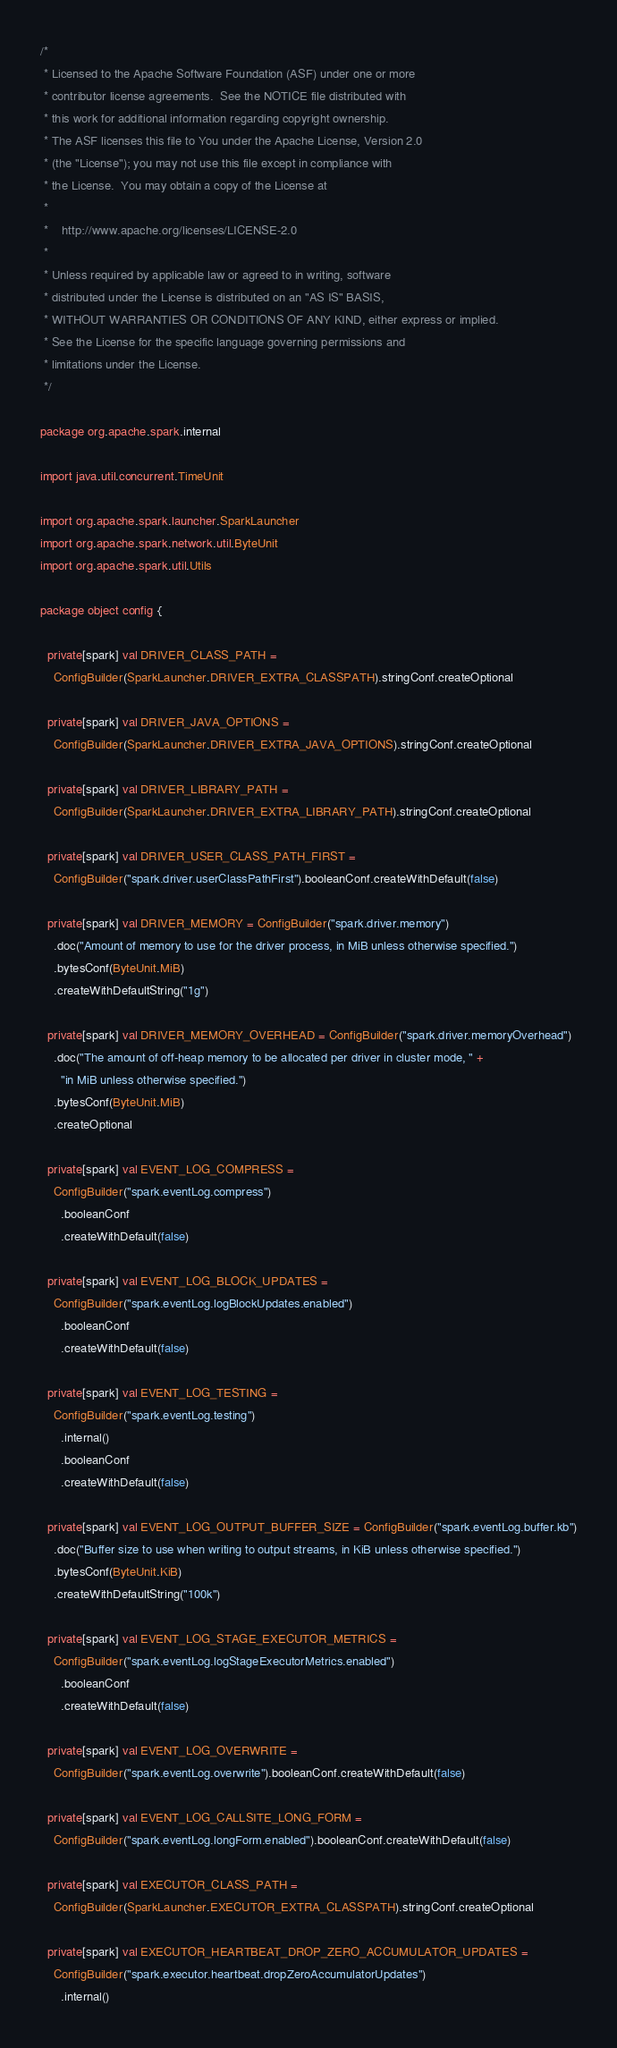<code> <loc_0><loc_0><loc_500><loc_500><_Scala_>/*
 * Licensed to the Apache Software Foundation (ASF) under one or more
 * contributor license agreements.  See the NOTICE file distributed with
 * this work for additional information regarding copyright ownership.
 * The ASF licenses this file to You under the Apache License, Version 2.0
 * (the "License"); you may not use this file except in compliance with
 * the License.  You may obtain a copy of the License at
 *
 *    http://www.apache.org/licenses/LICENSE-2.0
 *
 * Unless required by applicable law or agreed to in writing, software
 * distributed under the License is distributed on an "AS IS" BASIS,
 * WITHOUT WARRANTIES OR CONDITIONS OF ANY KIND, either express or implied.
 * See the License for the specific language governing permissions and
 * limitations under the License.
 */

package org.apache.spark.internal

import java.util.concurrent.TimeUnit

import org.apache.spark.launcher.SparkLauncher
import org.apache.spark.network.util.ByteUnit
import org.apache.spark.util.Utils

package object config {

  private[spark] val DRIVER_CLASS_PATH =
    ConfigBuilder(SparkLauncher.DRIVER_EXTRA_CLASSPATH).stringConf.createOptional

  private[spark] val DRIVER_JAVA_OPTIONS =
    ConfigBuilder(SparkLauncher.DRIVER_EXTRA_JAVA_OPTIONS).stringConf.createOptional

  private[spark] val DRIVER_LIBRARY_PATH =
    ConfigBuilder(SparkLauncher.DRIVER_EXTRA_LIBRARY_PATH).stringConf.createOptional

  private[spark] val DRIVER_USER_CLASS_PATH_FIRST =
    ConfigBuilder("spark.driver.userClassPathFirst").booleanConf.createWithDefault(false)

  private[spark] val DRIVER_MEMORY = ConfigBuilder("spark.driver.memory")
    .doc("Amount of memory to use for the driver process, in MiB unless otherwise specified.")
    .bytesConf(ByteUnit.MiB)
    .createWithDefaultString("1g")

  private[spark] val DRIVER_MEMORY_OVERHEAD = ConfigBuilder("spark.driver.memoryOverhead")
    .doc("The amount of off-heap memory to be allocated per driver in cluster mode, " +
      "in MiB unless otherwise specified.")
    .bytesConf(ByteUnit.MiB)
    .createOptional

  private[spark] val EVENT_LOG_COMPRESS =
    ConfigBuilder("spark.eventLog.compress")
      .booleanConf
      .createWithDefault(false)

  private[spark] val EVENT_LOG_BLOCK_UPDATES =
    ConfigBuilder("spark.eventLog.logBlockUpdates.enabled")
      .booleanConf
      .createWithDefault(false)

  private[spark] val EVENT_LOG_TESTING =
    ConfigBuilder("spark.eventLog.testing")
      .internal()
      .booleanConf
      .createWithDefault(false)

  private[spark] val EVENT_LOG_OUTPUT_BUFFER_SIZE = ConfigBuilder("spark.eventLog.buffer.kb")
    .doc("Buffer size to use when writing to output streams, in KiB unless otherwise specified.")
    .bytesConf(ByteUnit.KiB)
    .createWithDefaultString("100k")

  private[spark] val EVENT_LOG_STAGE_EXECUTOR_METRICS =
    ConfigBuilder("spark.eventLog.logStageExecutorMetrics.enabled")
      .booleanConf
      .createWithDefault(false)

  private[spark] val EVENT_LOG_OVERWRITE =
    ConfigBuilder("spark.eventLog.overwrite").booleanConf.createWithDefault(false)

  private[spark] val EVENT_LOG_CALLSITE_LONG_FORM =
    ConfigBuilder("spark.eventLog.longForm.enabled").booleanConf.createWithDefault(false)

  private[spark] val EXECUTOR_CLASS_PATH =
    ConfigBuilder(SparkLauncher.EXECUTOR_EXTRA_CLASSPATH).stringConf.createOptional

  private[spark] val EXECUTOR_HEARTBEAT_DROP_ZERO_ACCUMULATOR_UPDATES =
    ConfigBuilder("spark.executor.heartbeat.dropZeroAccumulatorUpdates")
      .internal()</code> 